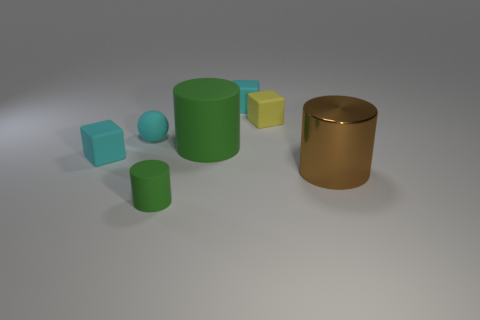What material is the cyan object that is behind the cyan matte sphere?
Provide a short and direct response. Rubber. Does the tiny green thing have the same shape as the big green object?
Keep it short and to the point. Yes. How many other objects are there of the same shape as the large green object?
Your answer should be very brief. 2. There is a tiny object that is on the left side of the matte sphere; what is its color?
Give a very brief answer. Cyan. Does the metal cylinder have the same size as the cyan rubber sphere?
Offer a terse response. No. There is a tiny cube that is on the left side of the small cyan matte thing behind the small yellow rubber block; what is its material?
Offer a terse response. Rubber. How many other spheres have the same color as the small rubber ball?
Keep it short and to the point. 0. Are there any other things that are the same material as the brown cylinder?
Provide a short and direct response. No. Is the number of large green things that are on the left side of the brown object less than the number of yellow matte things?
Provide a short and direct response. No. There is a matte thing behind the tiny yellow matte thing behind the small cylinder; what is its color?
Give a very brief answer. Cyan. 